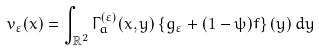<formula> <loc_0><loc_0><loc_500><loc_500>v _ { \varepsilon } ( x ) = \int _ { \mathbb { R } ^ { 2 } } \Gamma _ { a } ^ { ( \varepsilon ) } ( x , y ) \left \{ g _ { \varepsilon } + ( 1 - \psi ) f \right \} ( y ) \, d y</formula> 